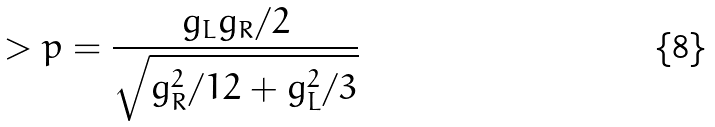Convert formula to latex. <formula><loc_0><loc_0><loc_500><loc_500>> p = \frac { g _ { L } g _ { R } / 2 } { \sqrt { g _ { R } ^ { 2 } / 1 2 + g _ { L } ^ { 2 } / 3 } }</formula> 